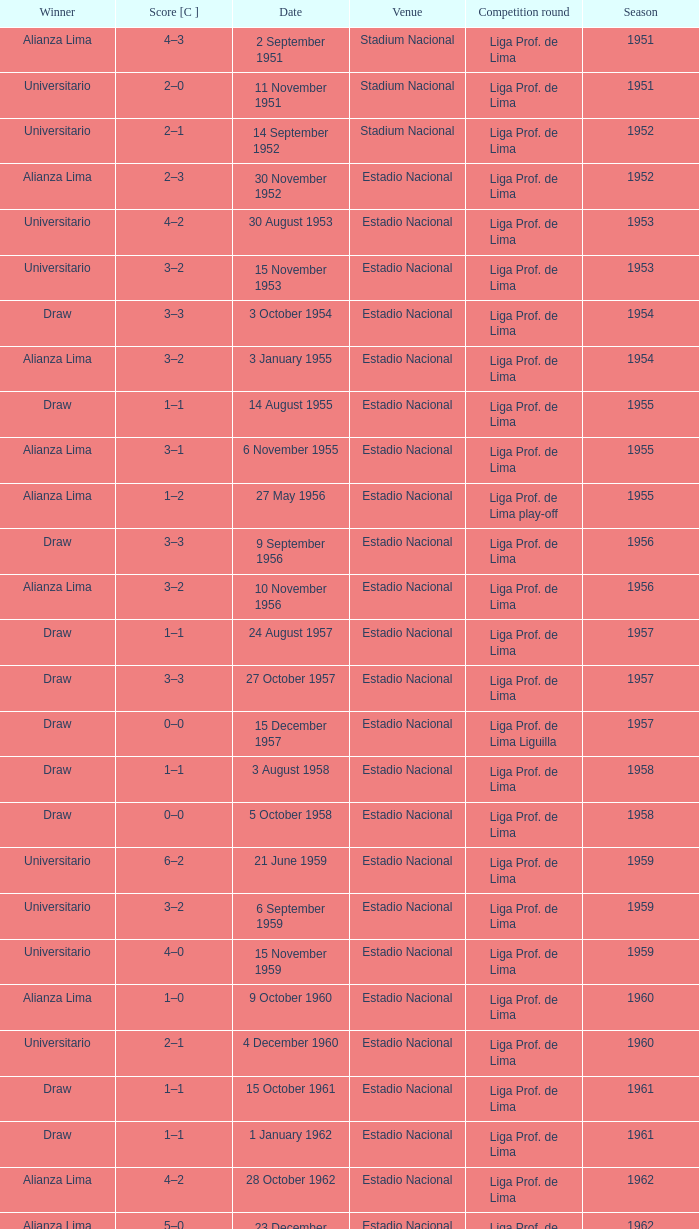What venue had an event on 17 November 1963? Estadio Nacional. 